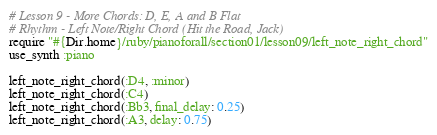Convert code to text. <code><loc_0><loc_0><loc_500><loc_500><_Ruby_># Lesson 9 - More Chords: D, E, A and B Flat
# Rhythm - Left Note/Right Chord (Hit the Road, Jack)
require "#{Dir.home}/ruby/pianoforall/section01/lesson09/left_note_right_chord"
use_synth :piano

left_note_right_chord(:D4, :minor)
left_note_right_chord(:C4)
left_note_right_chord(:Bb3, final_delay: 0.25)
left_note_right_chord(:A3, delay: 0.75)
</code> 